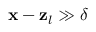<formula> <loc_0><loc_0><loc_500><loc_500>x - z _ { l } \gg \delta</formula> 